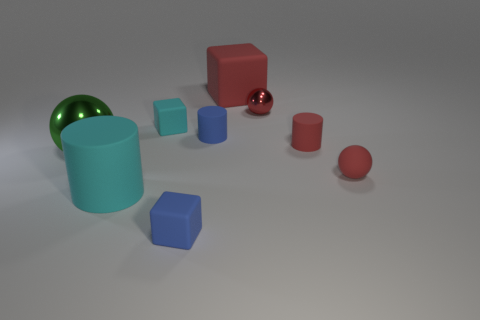Are there any large purple things?
Offer a terse response. No. Does the blue rubber object that is behind the large cyan thing have the same shape as the tiny red matte thing behind the large green shiny ball?
Keep it short and to the point. Yes. What number of tiny objects are blue matte things or matte spheres?
Your answer should be compact. 3. There is a small blue object that is the same material as the blue cube; what is its shape?
Provide a succinct answer. Cylinder. Is the shape of the tiny cyan object the same as the big red matte object?
Provide a short and direct response. Yes. What is the color of the small matte ball?
Provide a succinct answer. Red. How many things are large rubber cylinders or red blocks?
Ensure brevity in your answer.  2. Is the number of large cyan matte cylinders that are on the right side of the big red object less than the number of small blue metal cylinders?
Give a very brief answer. No. Are there more red cylinders behind the large cyan rubber cylinder than big spheres that are to the right of the large matte cube?
Provide a short and direct response. Yes. Is there any other thing of the same color as the big shiny object?
Provide a short and direct response. No. 